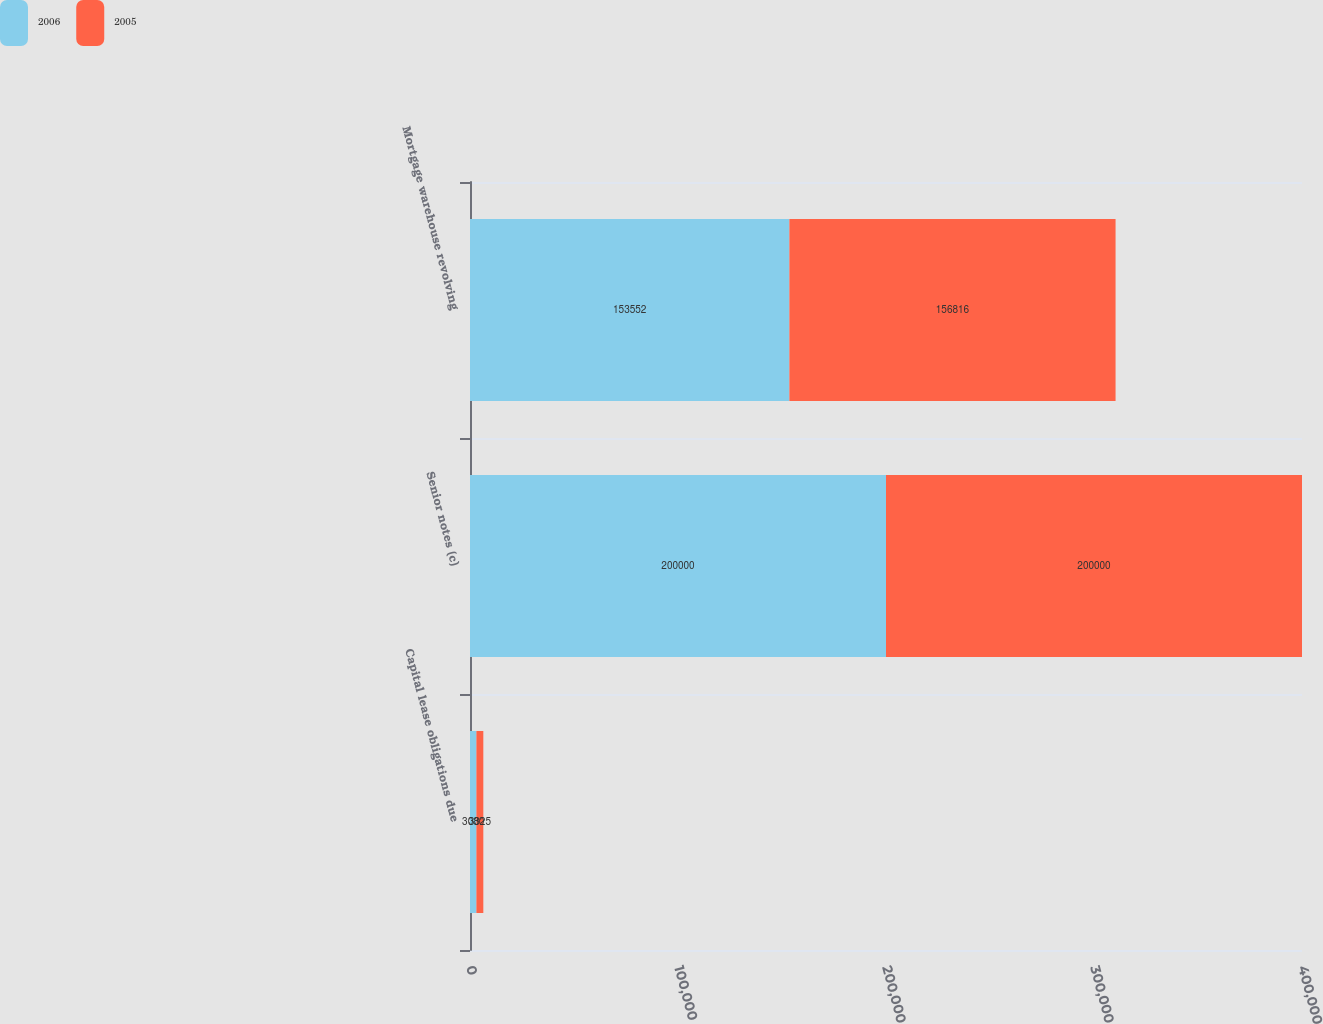Convert chart. <chart><loc_0><loc_0><loc_500><loc_500><stacked_bar_chart><ecel><fcel>Capital lease obligations due<fcel>Senior notes (c)<fcel>Mortgage warehouse revolving<nl><fcel>2006<fcel>3080<fcel>200000<fcel>153552<nl><fcel>2005<fcel>3325<fcel>200000<fcel>156816<nl></chart> 